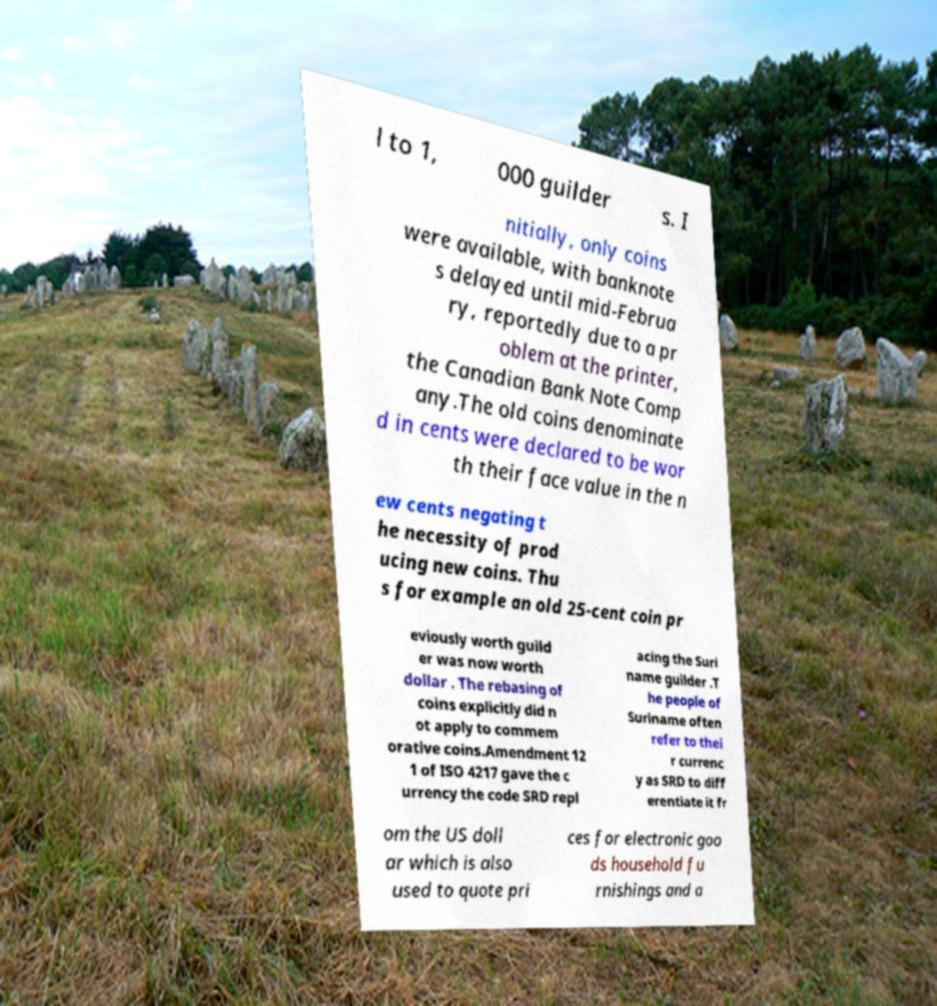Could you assist in decoding the text presented in this image and type it out clearly? l to 1, 000 guilder s. I nitially, only coins were available, with banknote s delayed until mid-Februa ry, reportedly due to a pr oblem at the printer, the Canadian Bank Note Comp any.The old coins denominate d in cents were declared to be wor th their face value in the n ew cents negating t he necessity of prod ucing new coins. Thu s for example an old 25-cent coin pr eviously worth guild er was now worth dollar . The rebasing of coins explicitly did n ot apply to commem orative coins.Amendment 12 1 of ISO 4217 gave the c urrency the code SRD repl acing the Suri name guilder .T he people of Suriname often refer to thei r currenc y as SRD to diff erentiate it fr om the US doll ar which is also used to quote pri ces for electronic goo ds household fu rnishings and a 